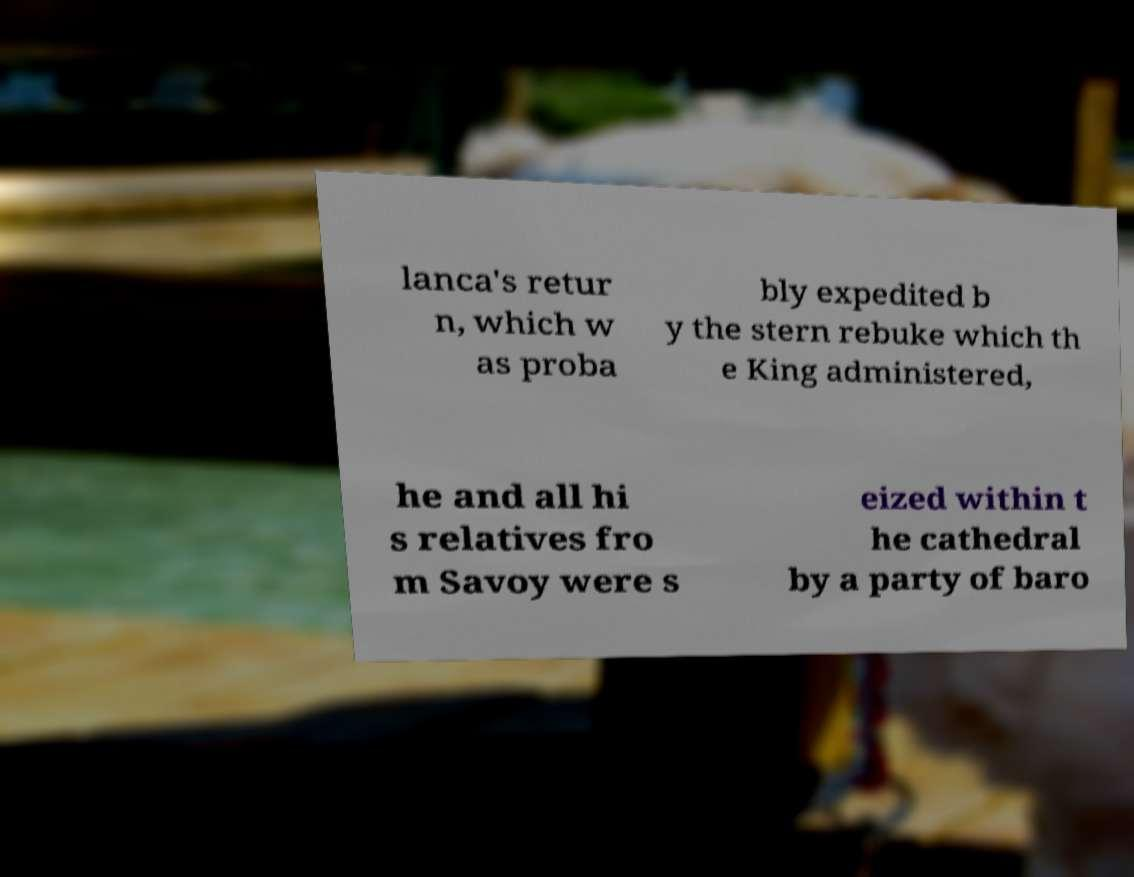Can you read and provide the text displayed in the image?This photo seems to have some interesting text. Can you extract and type it out for me? lanca's retur n, which w as proba bly expedited b y the stern rebuke which th e King administered, he and all hi s relatives fro m Savoy were s eized within t he cathedral by a party of baro 